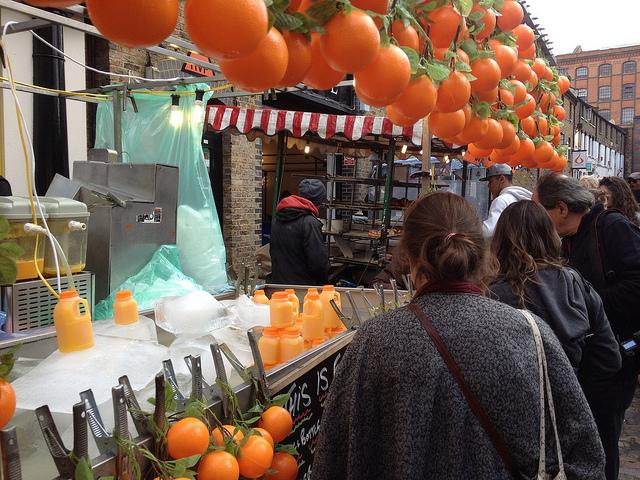What does this stand sell?
Answer briefly. Orange juice. What color are the caps on the plastic bottles?
Be succinct. Orange. What is stuck in the pile of ice?
Concise answer only. Orange juice. Are there vegetables present?
Keep it brief. No. Are these real oranges?
Quick response, please. No. 